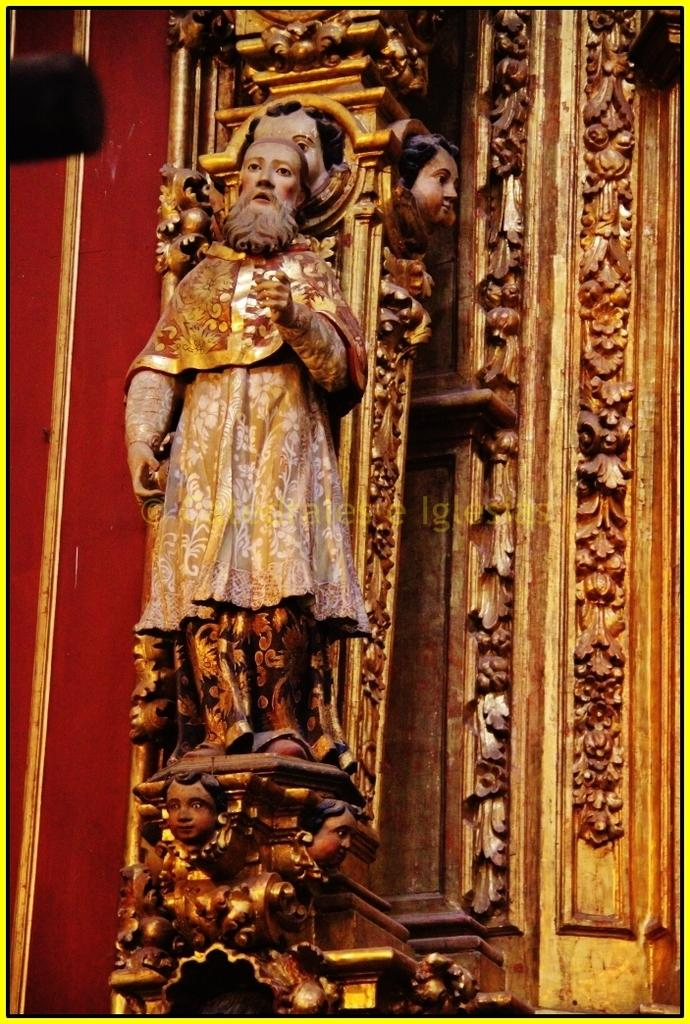What is the main subject of the image? There is a statue on a platform in the image. What can be seen on the left side of the image? There is a wall on the left side of the image. What is present on the platform with the statue? There are designs on the platform on the right side of the image. Can you tell me how many grapes are hanging from the statue in the image? There are no grapes present in the image; the statue and platform are the main subjects. Is there a trail visible in the image? There is no trail visible in the image; the focus is on the statue, platform, and wall. 